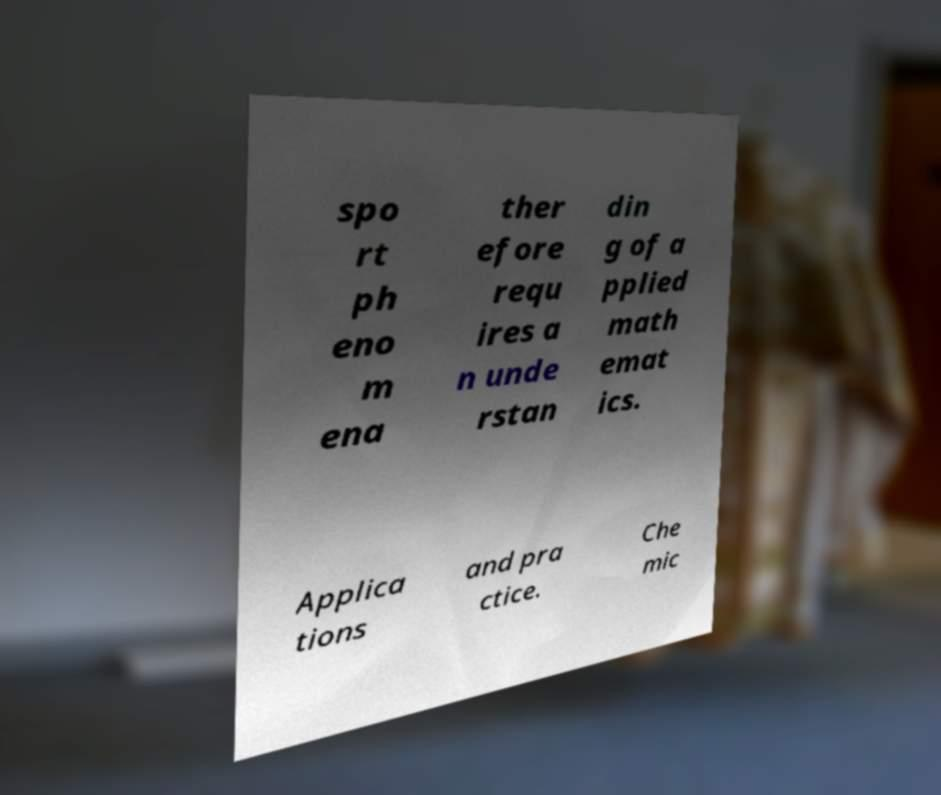There's text embedded in this image that I need extracted. Can you transcribe it verbatim? spo rt ph eno m ena ther efore requ ires a n unde rstan din g of a pplied math emat ics. Applica tions and pra ctice. Che mic 